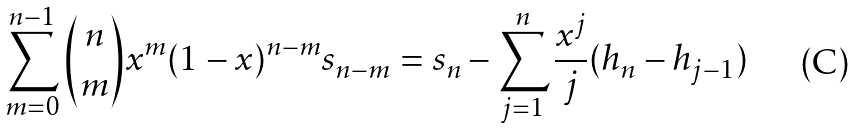Convert formula to latex. <formula><loc_0><loc_0><loc_500><loc_500>\sum _ { m = 0 } ^ { n - 1 } { n \choose m } x ^ { m } ( 1 - x ) ^ { n - m } s _ { n - m } = s _ { n } - \sum _ { j = 1 } ^ { n } \frac { x ^ { j } } { j } ( h _ { n } - h _ { j - 1 } )</formula> 